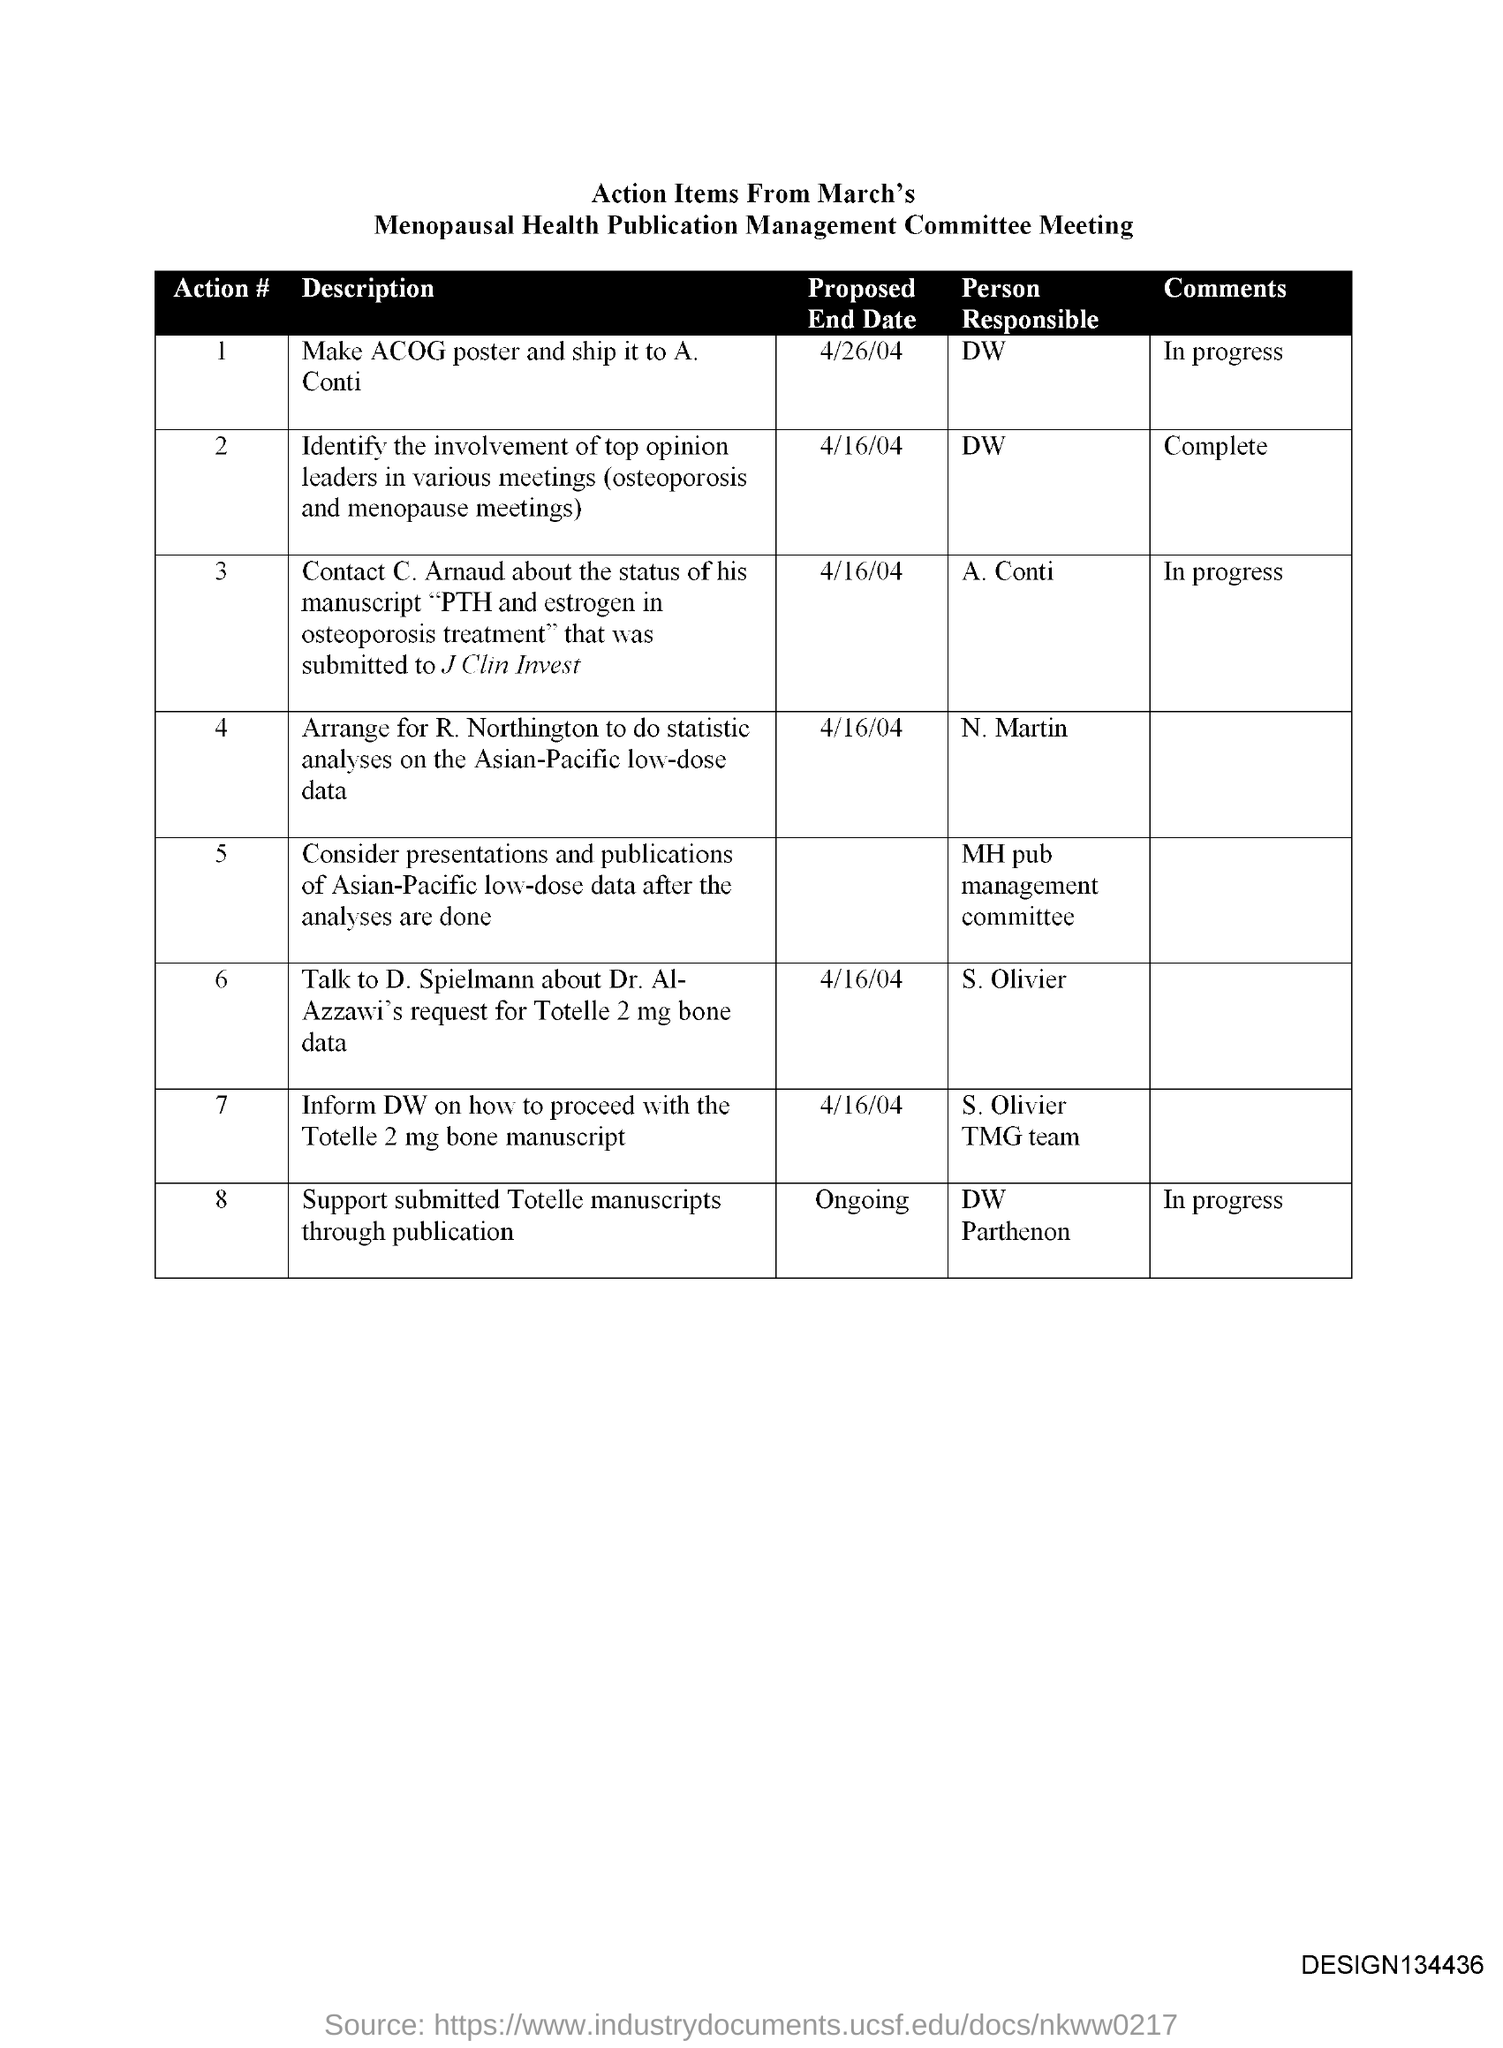Who is the person responsible for Action # 1?
Your answer should be very brief. DW. 